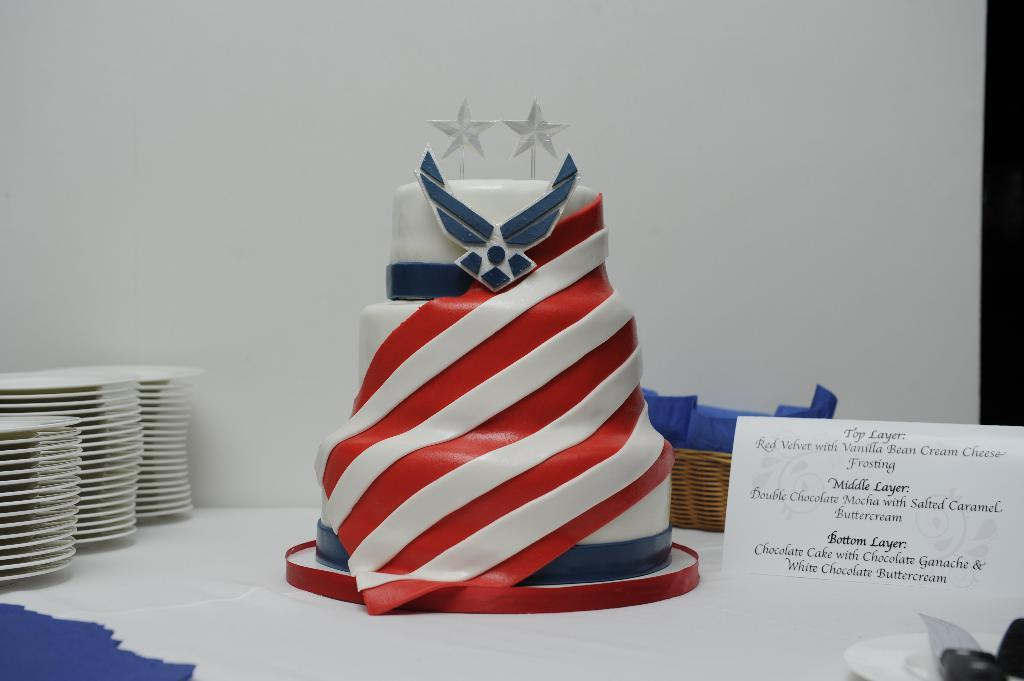What type of furniture is present in the image? The image contains a table. What is covering the table? There is a cloth on the table. What food item can be seen on the table? There is a cake on the table. What else is on the table besides the cake? There is a basket and plates on the table. Is there any paperwork on the table? Yes, there is a paper on the table. What can be seen in the background of the image? There is a wall in the background of the image. What does the dad say about the receipt in the image? There is no dad or receipt present in the image. 